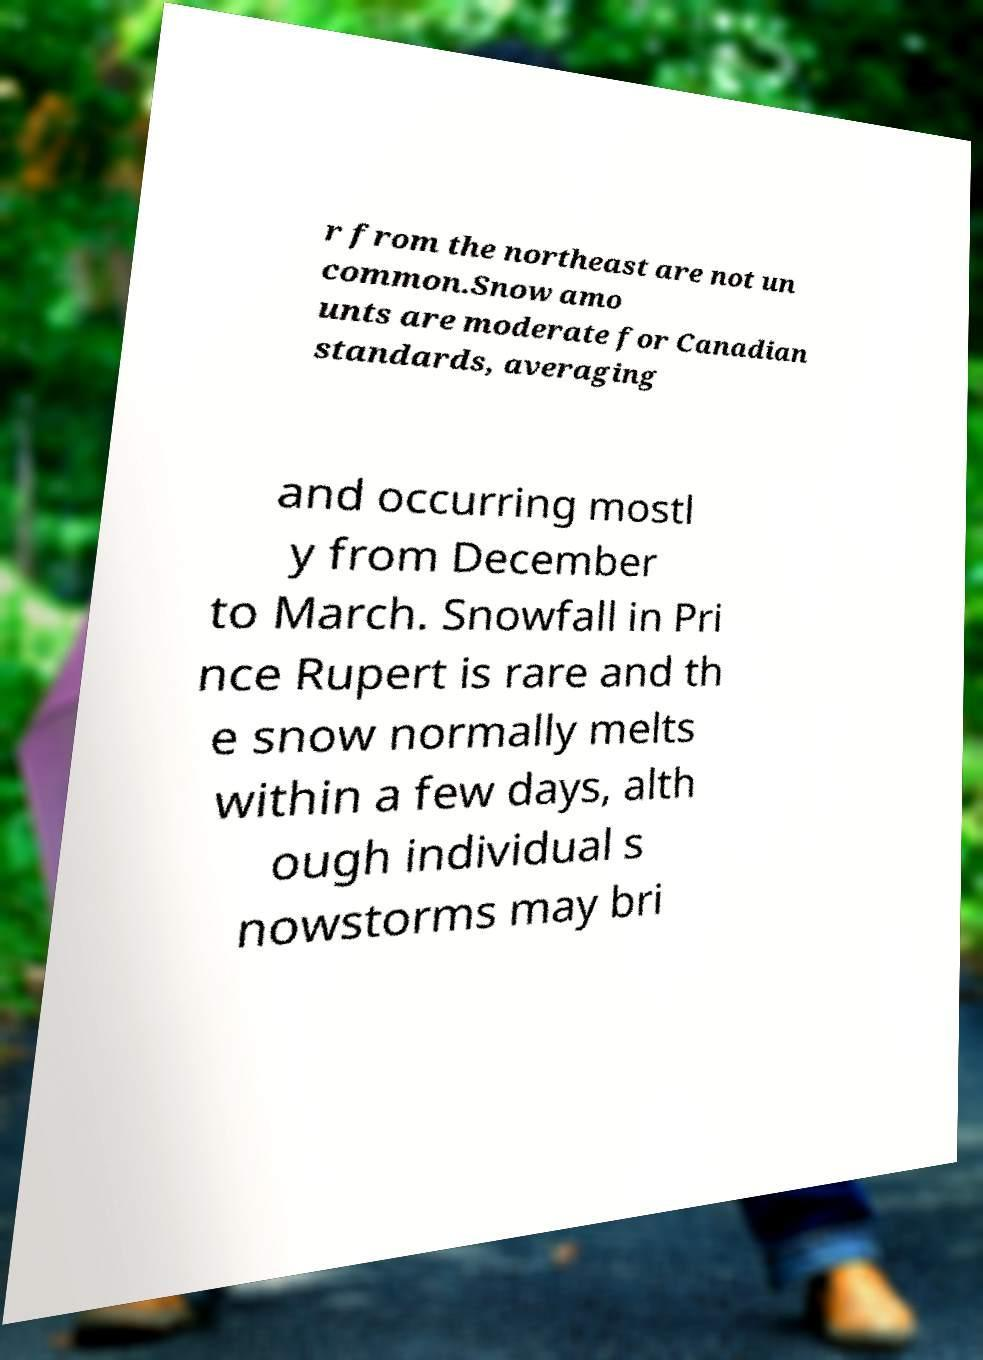Please read and relay the text visible in this image. What does it say? r from the northeast are not un common.Snow amo unts are moderate for Canadian standards, averaging and occurring mostl y from December to March. Snowfall in Pri nce Rupert is rare and th e snow normally melts within a few days, alth ough individual s nowstorms may bri 